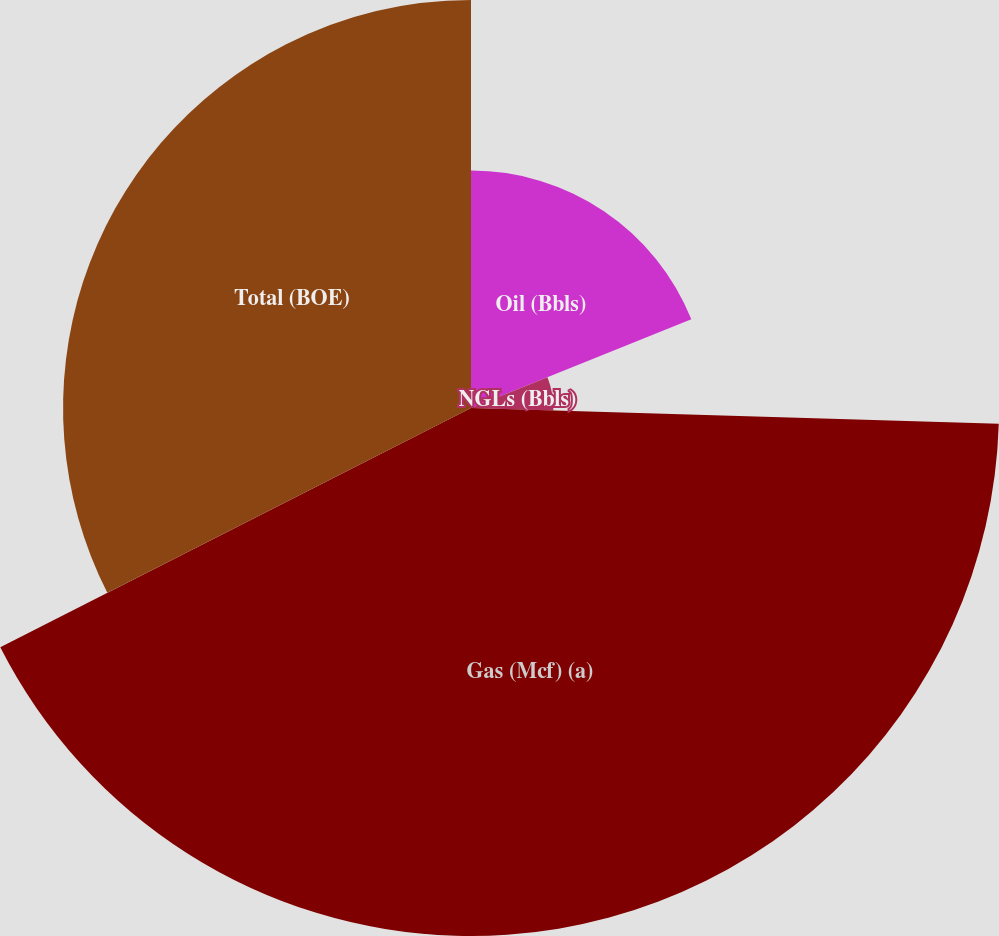Convert chart. <chart><loc_0><loc_0><loc_500><loc_500><pie_chart><fcel>Oil (Bbls)<fcel>NGLs (Bbls)<fcel>Gas (Mcf) (a)<fcel>Total (BOE)<nl><fcel>18.91%<fcel>6.56%<fcel>42.04%<fcel>32.48%<nl></chart> 